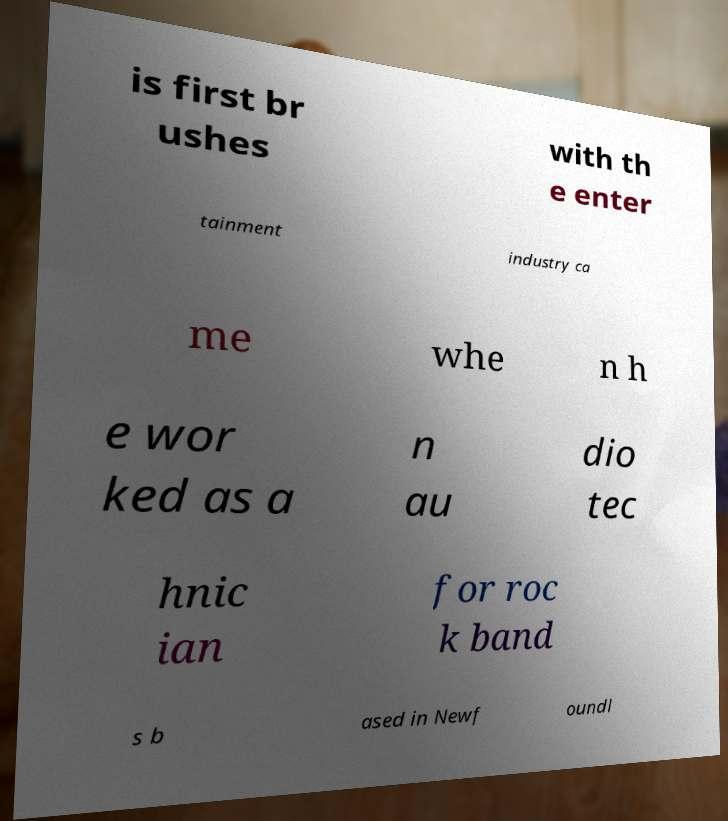Could you assist in decoding the text presented in this image and type it out clearly? is first br ushes with th e enter tainment industry ca me whe n h e wor ked as a n au dio tec hnic ian for roc k band s b ased in Newf oundl 